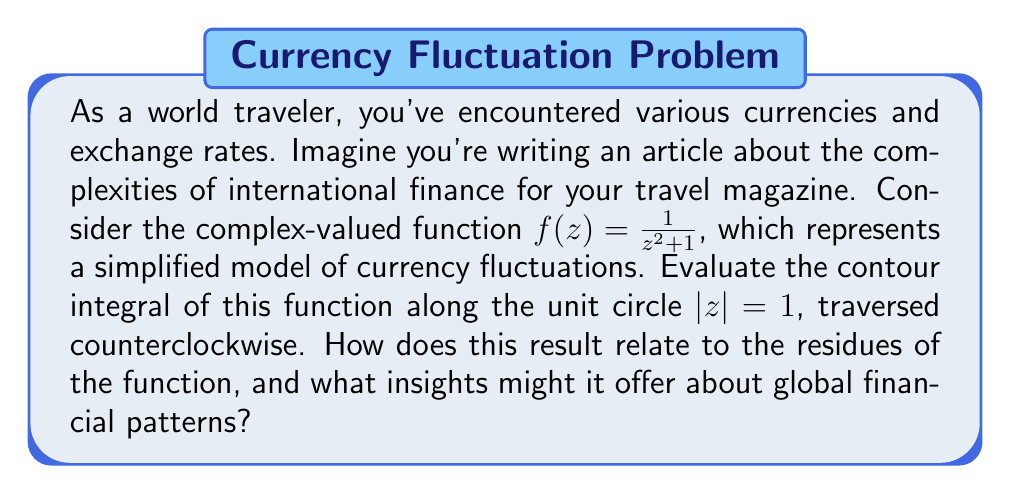Help me with this question. To evaluate this contour integral, we'll use the Residue Theorem. Let's approach this step-by-step:

1) First, we need to find the poles of the function $f(z) = \frac{1}{z^2 + 1}$ inside the unit circle.

   The poles are at $z = \pm i$. Only $z = i$ is inside the unit circle.

2) Next, we calculate the residue at $z = i$:

   $$\text{Res}(f, i) = \lim_{z \to i} (z-i) \frac{1}{z^2 + 1}$$

   $$= \lim_{z \to i} \frac{z-i}{(z+i)(z-i)} = \frac{1}{2i}$$

3) Now we can apply the Residue Theorem:

   $$\oint_{|z|=1} f(z) dz = 2\pi i \sum \text{Res}(f, a_k)$$

   Where $a_k$ are the poles inside the contour.

4) In this case, we only have one pole inside the contour, so:

   $$\oint_{|z|=1} f(z) dz = 2\pi i \cdot \frac{1}{2i} = \pi$$

5) Interpretation: The result $\pi$ is a real number, which in our financial model could represent a net change or flow in currency value after a complete cycle of fluctuations. The fact that it's positive suggests a overall positive trend in this simplified model.

6) The use of residues in this problem demonstrates how local behavior (near the poles) can determine global properties (the integral around the entire circle). In financial terms, this could be analogous to how specific events or policies in key financial centers can have far-reaching effects on global markets.
Answer: The contour integral $\oint_{|z|=1} \frac{1}{z^2 + 1} dz = \pi$. 